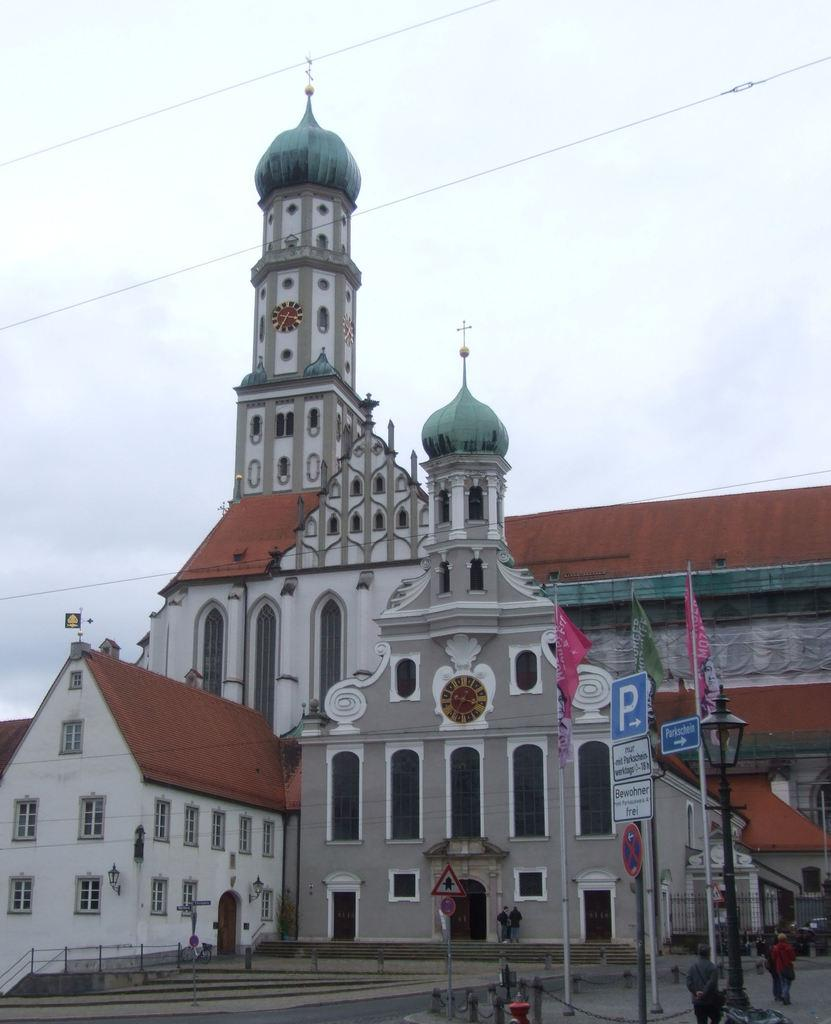Who or what is present in the image? There are people in the image. What can be seen in the image besides the people? There are flags and sign boards in the image. Where are the sign boards located in the image? The sign boards are at the bottom of the image. What is visible in the background of the image? There is a building in the background of the image. What is visible at the top of the image? The sky is visible at the top of the image. What type of wire can be seen connecting the flags in the image? There is no wire connecting the flags in the image; the flags are separate entities. What instrument is being played by the people in the image? There is no drum or any other instrument being played by the people in the image. 